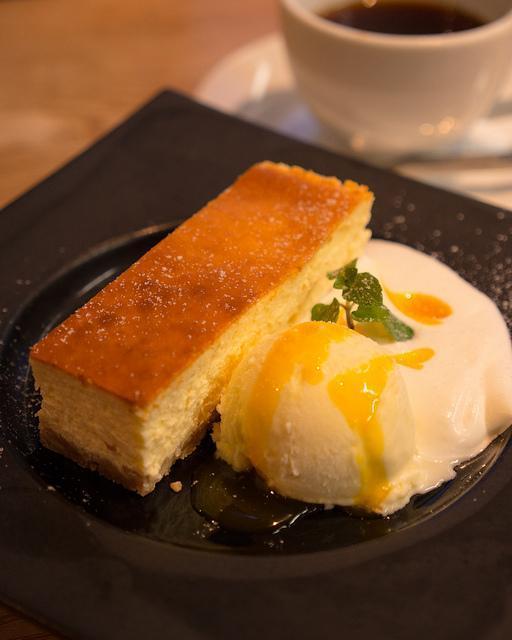How many spoons are there?
Give a very brief answer. 2. How many people are in the picture?
Give a very brief answer. 0. 